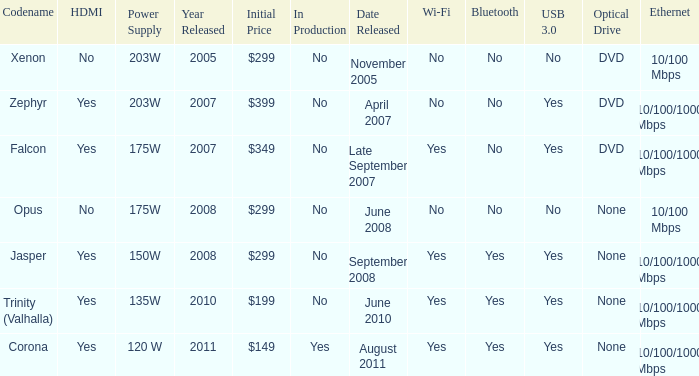Is Jasper being producted? No. 